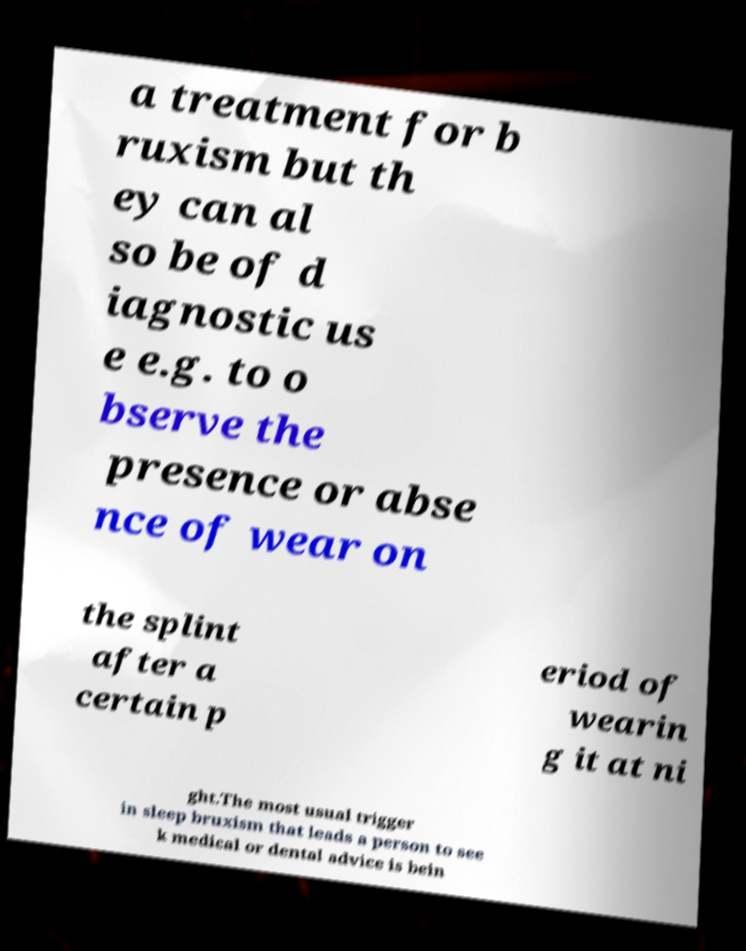Please read and relay the text visible in this image. What does it say? a treatment for b ruxism but th ey can al so be of d iagnostic us e e.g. to o bserve the presence or abse nce of wear on the splint after a certain p eriod of wearin g it at ni ght.The most usual trigger in sleep bruxism that leads a person to see k medical or dental advice is bein 